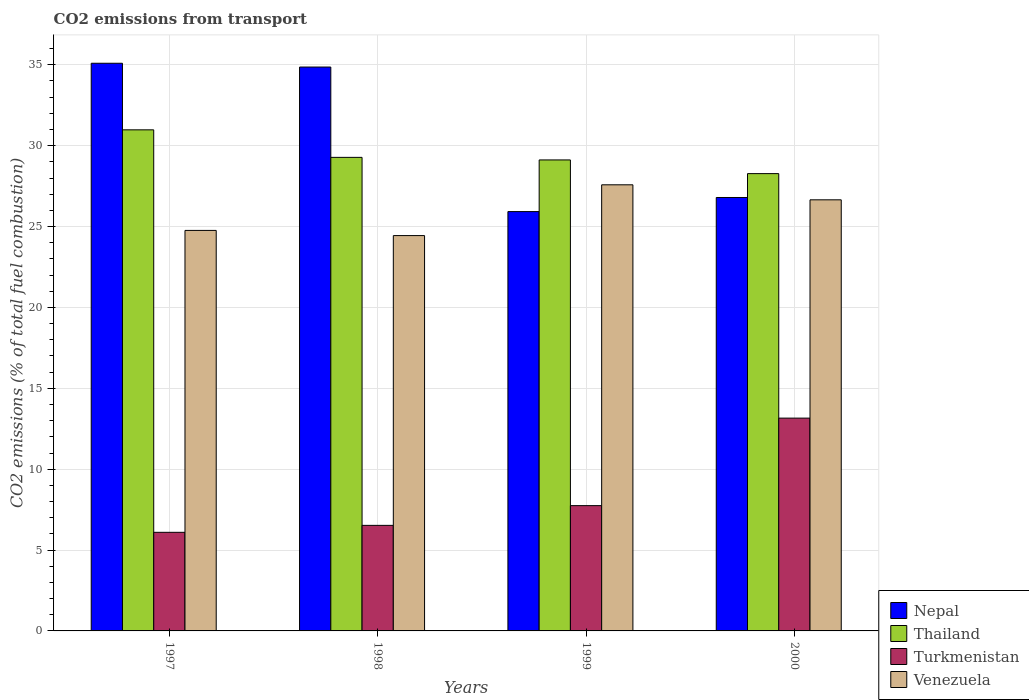How many different coloured bars are there?
Ensure brevity in your answer.  4. How many groups of bars are there?
Give a very brief answer. 4. Are the number of bars per tick equal to the number of legend labels?
Give a very brief answer. Yes. Are the number of bars on each tick of the X-axis equal?
Ensure brevity in your answer.  Yes. How many bars are there on the 3rd tick from the right?
Give a very brief answer. 4. What is the label of the 1st group of bars from the left?
Make the answer very short. 1997. In how many cases, is the number of bars for a given year not equal to the number of legend labels?
Offer a very short reply. 0. What is the total CO2 emitted in Venezuela in 1997?
Your answer should be very brief. 24.76. Across all years, what is the maximum total CO2 emitted in Turkmenistan?
Provide a succinct answer. 13.16. Across all years, what is the minimum total CO2 emitted in Turkmenistan?
Keep it short and to the point. 6.1. In which year was the total CO2 emitted in Venezuela minimum?
Provide a short and direct response. 1998. What is the total total CO2 emitted in Thailand in the graph?
Your answer should be compact. 117.65. What is the difference between the total CO2 emitted in Venezuela in 1997 and that in 1998?
Keep it short and to the point. 0.32. What is the difference between the total CO2 emitted in Turkmenistan in 2000 and the total CO2 emitted in Thailand in 1997?
Offer a very short reply. -17.82. What is the average total CO2 emitted in Nepal per year?
Ensure brevity in your answer.  30.67. In the year 1997, what is the difference between the total CO2 emitted in Venezuela and total CO2 emitted in Nepal?
Offer a very short reply. -10.33. In how many years, is the total CO2 emitted in Turkmenistan greater than 10?
Provide a succinct answer. 1. What is the ratio of the total CO2 emitted in Nepal in 1997 to that in 1998?
Give a very brief answer. 1.01. Is the total CO2 emitted in Turkmenistan in 1998 less than that in 2000?
Offer a terse response. Yes. Is the difference between the total CO2 emitted in Venezuela in 1998 and 2000 greater than the difference between the total CO2 emitted in Nepal in 1998 and 2000?
Provide a short and direct response. No. What is the difference between the highest and the second highest total CO2 emitted in Thailand?
Give a very brief answer. 1.7. What is the difference between the highest and the lowest total CO2 emitted in Nepal?
Keep it short and to the point. 9.17. In how many years, is the total CO2 emitted in Turkmenistan greater than the average total CO2 emitted in Turkmenistan taken over all years?
Keep it short and to the point. 1. Is the sum of the total CO2 emitted in Nepal in 1998 and 1999 greater than the maximum total CO2 emitted in Venezuela across all years?
Offer a terse response. Yes. What does the 2nd bar from the left in 1998 represents?
Your answer should be compact. Thailand. What does the 4th bar from the right in 1997 represents?
Provide a short and direct response. Nepal. Is it the case that in every year, the sum of the total CO2 emitted in Nepal and total CO2 emitted in Venezuela is greater than the total CO2 emitted in Turkmenistan?
Make the answer very short. Yes. Are all the bars in the graph horizontal?
Your answer should be very brief. No. How many years are there in the graph?
Offer a very short reply. 4. How many legend labels are there?
Ensure brevity in your answer.  4. What is the title of the graph?
Make the answer very short. CO2 emissions from transport. Does "El Salvador" appear as one of the legend labels in the graph?
Give a very brief answer. No. What is the label or title of the Y-axis?
Provide a short and direct response. CO2 emissions (% of total fuel combustion). What is the CO2 emissions (% of total fuel combustion) of Nepal in 1997?
Give a very brief answer. 35.1. What is the CO2 emissions (% of total fuel combustion) in Thailand in 1997?
Offer a very short reply. 30.98. What is the CO2 emissions (% of total fuel combustion) of Turkmenistan in 1997?
Keep it short and to the point. 6.1. What is the CO2 emissions (% of total fuel combustion) in Venezuela in 1997?
Your answer should be very brief. 24.76. What is the CO2 emissions (% of total fuel combustion) in Nepal in 1998?
Your answer should be compact. 34.86. What is the CO2 emissions (% of total fuel combustion) in Thailand in 1998?
Offer a very short reply. 29.28. What is the CO2 emissions (% of total fuel combustion) in Turkmenistan in 1998?
Keep it short and to the point. 6.53. What is the CO2 emissions (% of total fuel combustion) of Venezuela in 1998?
Offer a very short reply. 24.44. What is the CO2 emissions (% of total fuel combustion) of Nepal in 1999?
Offer a terse response. 25.93. What is the CO2 emissions (% of total fuel combustion) in Thailand in 1999?
Provide a short and direct response. 29.12. What is the CO2 emissions (% of total fuel combustion) in Turkmenistan in 1999?
Provide a succinct answer. 7.75. What is the CO2 emissions (% of total fuel combustion) in Venezuela in 1999?
Make the answer very short. 27.58. What is the CO2 emissions (% of total fuel combustion) of Nepal in 2000?
Offer a terse response. 26.8. What is the CO2 emissions (% of total fuel combustion) of Thailand in 2000?
Ensure brevity in your answer.  28.27. What is the CO2 emissions (% of total fuel combustion) in Turkmenistan in 2000?
Give a very brief answer. 13.16. What is the CO2 emissions (% of total fuel combustion) in Venezuela in 2000?
Keep it short and to the point. 26.65. Across all years, what is the maximum CO2 emissions (% of total fuel combustion) in Nepal?
Provide a succinct answer. 35.1. Across all years, what is the maximum CO2 emissions (% of total fuel combustion) of Thailand?
Offer a terse response. 30.98. Across all years, what is the maximum CO2 emissions (% of total fuel combustion) of Turkmenistan?
Keep it short and to the point. 13.16. Across all years, what is the maximum CO2 emissions (% of total fuel combustion) of Venezuela?
Ensure brevity in your answer.  27.58. Across all years, what is the minimum CO2 emissions (% of total fuel combustion) in Nepal?
Offer a very short reply. 25.93. Across all years, what is the minimum CO2 emissions (% of total fuel combustion) in Thailand?
Your answer should be compact. 28.27. Across all years, what is the minimum CO2 emissions (% of total fuel combustion) of Turkmenistan?
Give a very brief answer. 6.1. Across all years, what is the minimum CO2 emissions (% of total fuel combustion) of Venezuela?
Offer a terse response. 24.44. What is the total CO2 emissions (% of total fuel combustion) in Nepal in the graph?
Offer a terse response. 122.68. What is the total CO2 emissions (% of total fuel combustion) in Thailand in the graph?
Make the answer very short. 117.65. What is the total CO2 emissions (% of total fuel combustion) in Turkmenistan in the graph?
Your answer should be compact. 33.53. What is the total CO2 emissions (% of total fuel combustion) of Venezuela in the graph?
Keep it short and to the point. 103.44. What is the difference between the CO2 emissions (% of total fuel combustion) of Nepal in 1997 and that in 1998?
Your answer should be compact. 0.23. What is the difference between the CO2 emissions (% of total fuel combustion) in Thailand in 1997 and that in 1998?
Provide a succinct answer. 1.7. What is the difference between the CO2 emissions (% of total fuel combustion) in Turkmenistan in 1997 and that in 1998?
Make the answer very short. -0.43. What is the difference between the CO2 emissions (% of total fuel combustion) of Venezuela in 1997 and that in 1998?
Provide a short and direct response. 0.32. What is the difference between the CO2 emissions (% of total fuel combustion) of Nepal in 1997 and that in 1999?
Offer a terse response. 9.17. What is the difference between the CO2 emissions (% of total fuel combustion) in Thailand in 1997 and that in 1999?
Offer a very short reply. 1.86. What is the difference between the CO2 emissions (% of total fuel combustion) in Turkmenistan in 1997 and that in 1999?
Your answer should be very brief. -1.65. What is the difference between the CO2 emissions (% of total fuel combustion) in Venezuela in 1997 and that in 1999?
Offer a very short reply. -2.82. What is the difference between the CO2 emissions (% of total fuel combustion) in Nepal in 1997 and that in 2000?
Offer a very short reply. 8.3. What is the difference between the CO2 emissions (% of total fuel combustion) of Thailand in 1997 and that in 2000?
Provide a succinct answer. 2.71. What is the difference between the CO2 emissions (% of total fuel combustion) of Turkmenistan in 1997 and that in 2000?
Provide a succinct answer. -7.06. What is the difference between the CO2 emissions (% of total fuel combustion) in Venezuela in 1997 and that in 2000?
Ensure brevity in your answer.  -1.89. What is the difference between the CO2 emissions (% of total fuel combustion) of Nepal in 1998 and that in 1999?
Make the answer very short. 8.94. What is the difference between the CO2 emissions (% of total fuel combustion) of Thailand in 1998 and that in 1999?
Ensure brevity in your answer.  0.16. What is the difference between the CO2 emissions (% of total fuel combustion) in Turkmenistan in 1998 and that in 1999?
Your response must be concise. -1.22. What is the difference between the CO2 emissions (% of total fuel combustion) of Venezuela in 1998 and that in 1999?
Offer a very short reply. -3.14. What is the difference between the CO2 emissions (% of total fuel combustion) in Nepal in 1998 and that in 2000?
Your answer should be very brief. 8.06. What is the difference between the CO2 emissions (% of total fuel combustion) of Thailand in 1998 and that in 2000?
Make the answer very short. 1. What is the difference between the CO2 emissions (% of total fuel combustion) of Turkmenistan in 1998 and that in 2000?
Make the answer very short. -6.63. What is the difference between the CO2 emissions (% of total fuel combustion) in Venezuela in 1998 and that in 2000?
Provide a succinct answer. -2.21. What is the difference between the CO2 emissions (% of total fuel combustion) of Nepal in 1999 and that in 2000?
Keep it short and to the point. -0.87. What is the difference between the CO2 emissions (% of total fuel combustion) in Thailand in 1999 and that in 2000?
Offer a terse response. 0.85. What is the difference between the CO2 emissions (% of total fuel combustion) in Turkmenistan in 1999 and that in 2000?
Offer a terse response. -5.41. What is the difference between the CO2 emissions (% of total fuel combustion) of Venezuela in 1999 and that in 2000?
Provide a short and direct response. 0.93. What is the difference between the CO2 emissions (% of total fuel combustion) in Nepal in 1997 and the CO2 emissions (% of total fuel combustion) in Thailand in 1998?
Your answer should be very brief. 5.82. What is the difference between the CO2 emissions (% of total fuel combustion) of Nepal in 1997 and the CO2 emissions (% of total fuel combustion) of Turkmenistan in 1998?
Provide a short and direct response. 28.57. What is the difference between the CO2 emissions (% of total fuel combustion) of Nepal in 1997 and the CO2 emissions (% of total fuel combustion) of Venezuela in 1998?
Keep it short and to the point. 10.65. What is the difference between the CO2 emissions (% of total fuel combustion) in Thailand in 1997 and the CO2 emissions (% of total fuel combustion) in Turkmenistan in 1998?
Give a very brief answer. 24.45. What is the difference between the CO2 emissions (% of total fuel combustion) in Thailand in 1997 and the CO2 emissions (% of total fuel combustion) in Venezuela in 1998?
Ensure brevity in your answer.  6.54. What is the difference between the CO2 emissions (% of total fuel combustion) in Turkmenistan in 1997 and the CO2 emissions (% of total fuel combustion) in Venezuela in 1998?
Your answer should be very brief. -18.35. What is the difference between the CO2 emissions (% of total fuel combustion) in Nepal in 1997 and the CO2 emissions (% of total fuel combustion) in Thailand in 1999?
Your answer should be very brief. 5.98. What is the difference between the CO2 emissions (% of total fuel combustion) in Nepal in 1997 and the CO2 emissions (% of total fuel combustion) in Turkmenistan in 1999?
Give a very brief answer. 27.35. What is the difference between the CO2 emissions (% of total fuel combustion) of Nepal in 1997 and the CO2 emissions (% of total fuel combustion) of Venezuela in 1999?
Offer a very short reply. 7.51. What is the difference between the CO2 emissions (% of total fuel combustion) of Thailand in 1997 and the CO2 emissions (% of total fuel combustion) of Turkmenistan in 1999?
Offer a very short reply. 23.23. What is the difference between the CO2 emissions (% of total fuel combustion) in Thailand in 1997 and the CO2 emissions (% of total fuel combustion) in Venezuela in 1999?
Offer a terse response. 3.4. What is the difference between the CO2 emissions (% of total fuel combustion) of Turkmenistan in 1997 and the CO2 emissions (% of total fuel combustion) of Venezuela in 1999?
Your response must be concise. -21.48. What is the difference between the CO2 emissions (% of total fuel combustion) in Nepal in 1997 and the CO2 emissions (% of total fuel combustion) in Thailand in 2000?
Your answer should be compact. 6.82. What is the difference between the CO2 emissions (% of total fuel combustion) of Nepal in 1997 and the CO2 emissions (% of total fuel combustion) of Turkmenistan in 2000?
Your response must be concise. 21.94. What is the difference between the CO2 emissions (% of total fuel combustion) of Nepal in 1997 and the CO2 emissions (% of total fuel combustion) of Venezuela in 2000?
Ensure brevity in your answer.  8.44. What is the difference between the CO2 emissions (% of total fuel combustion) of Thailand in 1997 and the CO2 emissions (% of total fuel combustion) of Turkmenistan in 2000?
Ensure brevity in your answer.  17.82. What is the difference between the CO2 emissions (% of total fuel combustion) in Thailand in 1997 and the CO2 emissions (% of total fuel combustion) in Venezuela in 2000?
Keep it short and to the point. 4.33. What is the difference between the CO2 emissions (% of total fuel combustion) in Turkmenistan in 1997 and the CO2 emissions (% of total fuel combustion) in Venezuela in 2000?
Ensure brevity in your answer.  -20.56. What is the difference between the CO2 emissions (% of total fuel combustion) of Nepal in 1998 and the CO2 emissions (% of total fuel combustion) of Thailand in 1999?
Your answer should be very brief. 5.74. What is the difference between the CO2 emissions (% of total fuel combustion) in Nepal in 1998 and the CO2 emissions (% of total fuel combustion) in Turkmenistan in 1999?
Provide a succinct answer. 27.12. What is the difference between the CO2 emissions (% of total fuel combustion) in Nepal in 1998 and the CO2 emissions (% of total fuel combustion) in Venezuela in 1999?
Your response must be concise. 7.28. What is the difference between the CO2 emissions (% of total fuel combustion) in Thailand in 1998 and the CO2 emissions (% of total fuel combustion) in Turkmenistan in 1999?
Provide a short and direct response. 21.53. What is the difference between the CO2 emissions (% of total fuel combustion) of Thailand in 1998 and the CO2 emissions (% of total fuel combustion) of Venezuela in 1999?
Your answer should be compact. 1.7. What is the difference between the CO2 emissions (% of total fuel combustion) in Turkmenistan in 1998 and the CO2 emissions (% of total fuel combustion) in Venezuela in 1999?
Keep it short and to the point. -21.06. What is the difference between the CO2 emissions (% of total fuel combustion) of Nepal in 1998 and the CO2 emissions (% of total fuel combustion) of Thailand in 2000?
Offer a very short reply. 6.59. What is the difference between the CO2 emissions (% of total fuel combustion) in Nepal in 1998 and the CO2 emissions (% of total fuel combustion) in Turkmenistan in 2000?
Your answer should be very brief. 21.71. What is the difference between the CO2 emissions (% of total fuel combustion) of Nepal in 1998 and the CO2 emissions (% of total fuel combustion) of Venezuela in 2000?
Provide a succinct answer. 8.21. What is the difference between the CO2 emissions (% of total fuel combustion) in Thailand in 1998 and the CO2 emissions (% of total fuel combustion) in Turkmenistan in 2000?
Provide a succinct answer. 16.12. What is the difference between the CO2 emissions (% of total fuel combustion) of Thailand in 1998 and the CO2 emissions (% of total fuel combustion) of Venezuela in 2000?
Make the answer very short. 2.62. What is the difference between the CO2 emissions (% of total fuel combustion) of Turkmenistan in 1998 and the CO2 emissions (% of total fuel combustion) of Venezuela in 2000?
Offer a very short reply. -20.13. What is the difference between the CO2 emissions (% of total fuel combustion) of Nepal in 1999 and the CO2 emissions (% of total fuel combustion) of Thailand in 2000?
Offer a very short reply. -2.35. What is the difference between the CO2 emissions (% of total fuel combustion) in Nepal in 1999 and the CO2 emissions (% of total fuel combustion) in Turkmenistan in 2000?
Provide a succinct answer. 12.77. What is the difference between the CO2 emissions (% of total fuel combustion) in Nepal in 1999 and the CO2 emissions (% of total fuel combustion) in Venezuela in 2000?
Your answer should be compact. -0.73. What is the difference between the CO2 emissions (% of total fuel combustion) of Thailand in 1999 and the CO2 emissions (% of total fuel combustion) of Turkmenistan in 2000?
Your response must be concise. 15.96. What is the difference between the CO2 emissions (% of total fuel combustion) of Thailand in 1999 and the CO2 emissions (% of total fuel combustion) of Venezuela in 2000?
Offer a very short reply. 2.47. What is the difference between the CO2 emissions (% of total fuel combustion) in Turkmenistan in 1999 and the CO2 emissions (% of total fuel combustion) in Venezuela in 2000?
Offer a very short reply. -18.91. What is the average CO2 emissions (% of total fuel combustion) of Nepal per year?
Provide a succinct answer. 30.67. What is the average CO2 emissions (% of total fuel combustion) of Thailand per year?
Offer a terse response. 29.41. What is the average CO2 emissions (% of total fuel combustion) of Turkmenistan per year?
Your response must be concise. 8.38. What is the average CO2 emissions (% of total fuel combustion) of Venezuela per year?
Your response must be concise. 25.86. In the year 1997, what is the difference between the CO2 emissions (% of total fuel combustion) in Nepal and CO2 emissions (% of total fuel combustion) in Thailand?
Provide a succinct answer. 4.12. In the year 1997, what is the difference between the CO2 emissions (% of total fuel combustion) in Nepal and CO2 emissions (% of total fuel combustion) in Turkmenistan?
Your answer should be compact. 29. In the year 1997, what is the difference between the CO2 emissions (% of total fuel combustion) of Nepal and CO2 emissions (% of total fuel combustion) of Venezuela?
Keep it short and to the point. 10.33. In the year 1997, what is the difference between the CO2 emissions (% of total fuel combustion) of Thailand and CO2 emissions (% of total fuel combustion) of Turkmenistan?
Provide a short and direct response. 24.88. In the year 1997, what is the difference between the CO2 emissions (% of total fuel combustion) of Thailand and CO2 emissions (% of total fuel combustion) of Venezuela?
Your response must be concise. 6.22. In the year 1997, what is the difference between the CO2 emissions (% of total fuel combustion) in Turkmenistan and CO2 emissions (% of total fuel combustion) in Venezuela?
Give a very brief answer. -18.67. In the year 1998, what is the difference between the CO2 emissions (% of total fuel combustion) in Nepal and CO2 emissions (% of total fuel combustion) in Thailand?
Your response must be concise. 5.58. In the year 1998, what is the difference between the CO2 emissions (% of total fuel combustion) in Nepal and CO2 emissions (% of total fuel combustion) in Turkmenistan?
Make the answer very short. 28.34. In the year 1998, what is the difference between the CO2 emissions (% of total fuel combustion) in Nepal and CO2 emissions (% of total fuel combustion) in Venezuela?
Provide a short and direct response. 10.42. In the year 1998, what is the difference between the CO2 emissions (% of total fuel combustion) of Thailand and CO2 emissions (% of total fuel combustion) of Turkmenistan?
Provide a succinct answer. 22.75. In the year 1998, what is the difference between the CO2 emissions (% of total fuel combustion) in Thailand and CO2 emissions (% of total fuel combustion) in Venezuela?
Offer a terse response. 4.84. In the year 1998, what is the difference between the CO2 emissions (% of total fuel combustion) of Turkmenistan and CO2 emissions (% of total fuel combustion) of Venezuela?
Provide a short and direct response. -17.92. In the year 1999, what is the difference between the CO2 emissions (% of total fuel combustion) in Nepal and CO2 emissions (% of total fuel combustion) in Thailand?
Provide a short and direct response. -3.19. In the year 1999, what is the difference between the CO2 emissions (% of total fuel combustion) in Nepal and CO2 emissions (% of total fuel combustion) in Turkmenistan?
Offer a terse response. 18.18. In the year 1999, what is the difference between the CO2 emissions (% of total fuel combustion) of Nepal and CO2 emissions (% of total fuel combustion) of Venezuela?
Make the answer very short. -1.66. In the year 1999, what is the difference between the CO2 emissions (% of total fuel combustion) in Thailand and CO2 emissions (% of total fuel combustion) in Turkmenistan?
Your answer should be very brief. 21.37. In the year 1999, what is the difference between the CO2 emissions (% of total fuel combustion) of Thailand and CO2 emissions (% of total fuel combustion) of Venezuela?
Provide a succinct answer. 1.54. In the year 1999, what is the difference between the CO2 emissions (% of total fuel combustion) of Turkmenistan and CO2 emissions (% of total fuel combustion) of Venezuela?
Provide a succinct answer. -19.83. In the year 2000, what is the difference between the CO2 emissions (% of total fuel combustion) in Nepal and CO2 emissions (% of total fuel combustion) in Thailand?
Your response must be concise. -1.48. In the year 2000, what is the difference between the CO2 emissions (% of total fuel combustion) in Nepal and CO2 emissions (% of total fuel combustion) in Turkmenistan?
Offer a very short reply. 13.64. In the year 2000, what is the difference between the CO2 emissions (% of total fuel combustion) in Nepal and CO2 emissions (% of total fuel combustion) in Venezuela?
Your response must be concise. 0.14. In the year 2000, what is the difference between the CO2 emissions (% of total fuel combustion) of Thailand and CO2 emissions (% of total fuel combustion) of Turkmenistan?
Provide a short and direct response. 15.12. In the year 2000, what is the difference between the CO2 emissions (% of total fuel combustion) of Thailand and CO2 emissions (% of total fuel combustion) of Venezuela?
Your response must be concise. 1.62. In the year 2000, what is the difference between the CO2 emissions (% of total fuel combustion) of Turkmenistan and CO2 emissions (% of total fuel combustion) of Venezuela?
Keep it short and to the point. -13.5. What is the ratio of the CO2 emissions (% of total fuel combustion) in Nepal in 1997 to that in 1998?
Provide a succinct answer. 1.01. What is the ratio of the CO2 emissions (% of total fuel combustion) of Thailand in 1997 to that in 1998?
Ensure brevity in your answer.  1.06. What is the ratio of the CO2 emissions (% of total fuel combustion) in Turkmenistan in 1997 to that in 1998?
Provide a succinct answer. 0.93. What is the ratio of the CO2 emissions (% of total fuel combustion) in Venezuela in 1997 to that in 1998?
Offer a terse response. 1.01. What is the ratio of the CO2 emissions (% of total fuel combustion) in Nepal in 1997 to that in 1999?
Your response must be concise. 1.35. What is the ratio of the CO2 emissions (% of total fuel combustion) in Thailand in 1997 to that in 1999?
Ensure brevity in your answer.  1.06. What is the ratio of the CO2 emissions (% of total fuel combustion) of Turkmenistan in 1997 to that in 1999?
Keep it short and to the point. 0.79. What is the ratio of the CO2 emissions (% of total fuel combustion) in Venezuela in 1997 to that in 1999?
Provide a succinct answer. 0.9. What is the ratio of the CO2 emissions (% of total fuel combustion) in Nepal in 1997 to that in 2000?
Provide a short and direct response. 1.31. What is the ratio of the CO2 emissions (% of total fuel combustion) of Thailand in 1997 to that in 2000?
Offer a very short reply. 1.1. What is the ratio of the CO2 emissions (% of total fuel combustion) in Turkmenistan in 1997 to that in 2000?
Ensure brevity in your answer.  0.46. What is the ratio of the CO2 emissions (% of total fuel combustion) of Venezuela in 1997 to that in 2000?
Your answer should be very brief. 0.93. What is the ratio of the CO2 emissions (% of total fuel combustion) of Nepal in 1998 to that in 1999?
Offer a very short reply. 1.34. What is the ratio of the CO2 emissions (% of total fuel combustion) in Thailand in 1998 to that in 1999?
Provide a succinct answer. 1.01. What is the ratio of the CO2 emissions (% of total fuel combustion) of Turkmenistan in 1998 to that in 1999?
Your answer should be very brief. 0.84. What is the ratio of the CO2 emissions (% of total fuel combustion) of Venezuela in 1998 to that in 1999?
Your answer should be very brief. 0.89. What is the ratio of the CO2 emissions (% of total fuel combustion) of Nepal in 1998 to that in 2000?
Give a very brief answer. 1.3. What is the ratio of the CO2 emissions (% of total fuel combustion) of Thailand in 1998 to that in 2000?
Provide a succinct answer. 1.04. What is the ratio of the CO2 emissions (% of total fuel combustion) in Turkmenistan in 1998 to that in 2000?
Keep it short and to the point. 0.5. What is the ratio of the CO2 emissions (% of total fuel combustion) in Venezuela in 1998 to that in 2000?
Your answer should be very brief. 0.92. What is the ratio of the CO2 emissions (% of total fuel combustion) of Nepal in 1999 to that in 2000?
Ensure brevity in your answer.  0.97. What is the ratio of the CO2 emissions (% of total fuel combustion) in Thailand in 1999 to that in 2000?
Keep it short and to the point. 1.03. What is the ratio of the CO2 emissions (% of total fuel combustion) of Turkmenistan in 1999 to that in 2000?
Keep it short and to the point. 0.59. What is the ratio of the CO2 emissions (% of total fuel combustion) of Venezuela in 1999 to that in 2000?
Your answer should be compact. 1.03. What is the difference between the highest and the second highest CO2 emissions (% of total fuel combustion) of Nepal?
Offer a very short reply. 0.23. What is the difference between the highest and the second highest CO2 emissions (% of total fuel combustion) in Thailand?
Provide a succinct answer. 1.7. What is the difference between the highest and the second highest CO2 emissions (% of total fuel combustion) in Turkmenistan?
Your answer should be compact. 5.41. What is the difference between the highest and the second highest CO2 emissions (% of total fuel combustion) of Venezuela?
Provide a short and direct response. 0.93. What is the difference between the highest and the lowest CO2 emissions (% of total fuel combustion) in Nepal?
Your answer should be very brief. 9.17. What is the difference between the highest and the lowest CO2 emissions (% of total fuel combustion) of Thailand?
Your response must be concise. 2.71. What is the difference between the highest and the lowest CO2 emissions (% of total fuel combustion) in Turkmenistan?
Offer a terse response. 7.06. What is the difference between the highest and the lowest CO2 emissions (% of total fuel combustion) in Venezuela?
Your answer should be compact. 3.14. 